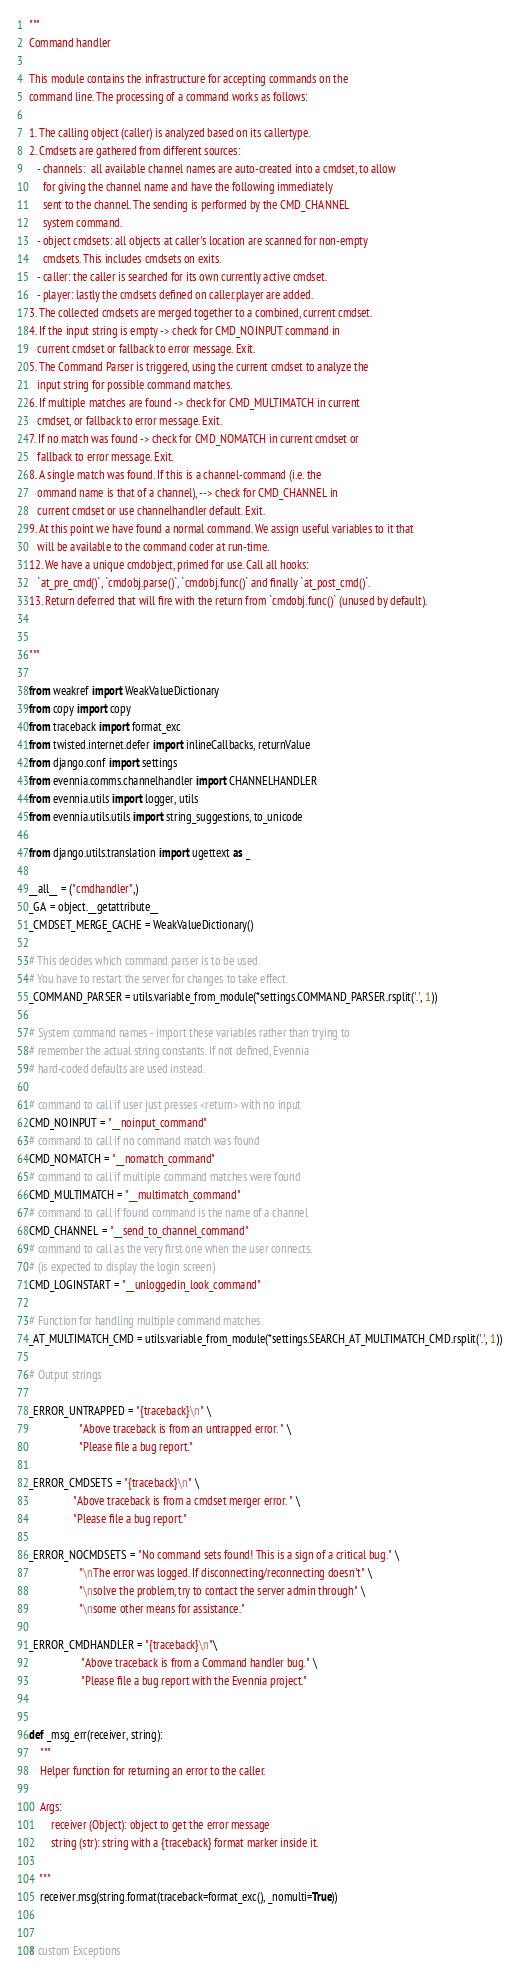<code> <loc_0><loc_0><loc_500><loc_500><_Python_>"""
Command handler

This module contains the infrastructure for accepting commands on the
command line. The processing of a command works as follows:

1. The calling object (caller) is analyzed based on its callertype.
2. Cmdsets are gathered from different sources:
   - channels:  all available channel names are auto-created into a cmdset, to allow
     for giving the channel name and have the following immediately
     sent to the channel. The sending is performed by the CMD_CHANNEL
     system command.
   - object cmdsets: all objects at caller's location are scanned for non-empty
     cmdsets. This includes cmdsets on exits.
   - caller: the caller is searched for its own currently active cmdset.
   - player: lastly the cmdsets defined on caller.player are added.
3. The collected cmdsets are merged together to a combined, current cmdset.
4. If the input string is empty -> check for CMD_NOINPUT command in
   current cmdset or fallback to error message. Exit.
5. The Command Parser is triggered, using the current cmdset to analyze the
   input string for possible command matches.
6. If multiple matches are found -> check for CMD_MULTIMATCH in current
   cmdset, or fallback to error message. Exit.
7. If no match was found -> check for CMD_NOMATCH in current cmdset or
   fallback to error message. Exit.
8. A single match was found. If this is a channel-command (i.e. the
   ommand name is that of a channel), --> check for CMD_CHANNEL in
   current cmdset or use channelhandler default. Exit.
9. At this point we have found a normal command. We assign useful variables to it that
   will be available to the command coder at run-time.
12. We have a unique cmdobject, primed for use. Call all hooks:
   `at_pre_cmd()`, `cmdobj.parse()`, `cmdobj.func()` and finally `at_post_cmd()`.
13. Return deferred that will fire with the return from `cmdobj.func()` (unused by default).


"""

from weakref import WeakValueDictionary
from copy import copy
from traceback import format_exc
from twisted.internet.defer import inlineCallbacks, returnValue
from django.conf import settings
from evennia.comms.channelhandler import CHANNELHANDLER
from evennia.utils import logger, utils
from evennia.utils.utils import string_suggestions, to_unicode

from django.utils.translation import ugettext as _

__all__ = ("cmdhandler",)
_GA = object.__getattribute__
_CMDSET_MERGE_CACHE = WeakValueDictionary()

# This decides which command parser is to be used.
# You have to restart the server for changes to take effect.
_COMMAND_PARSER = utils.variable_from_module(*settings.COMMAND_PARSER.rsplit('.', 1))

# System command names - import these variables rather than trying to
# remember the actual string constants. If not defined, Evennia
# hard-coded defaults are used instead.

# command to call if user just presses <return> with no input
CMD_NOINPUT = "__noinput_command"
# command to call if no command match was found
CMD_NOMATCH = "__nomatch_command"
# command to call if multiple command matches were found
CMD_MULTIMATCH = "__multimatch_command"
# command to call if found command is the name of a channel
CMD_CHANNEL = "__send_to_channel_command"
# command to call as the very first one when the user connects.
# (is expected to display the login screen)
CMD_LOGINSTART = "__unloggedin_look_command"

# Function for handling multiple command matches.
_AT_MULTIMATCH_CMD = utils.variable_from_module(*settings.SEARCH_AT_MULTIMATCH_CMD.rsplit('.', 1))

# Output strings

_ERROR_UNTRAPPED = "{traceback}\n" \
                  "Above traceback is from an untrapped error. " \
                  "Please file a bug report."

_ERROR_CMDSETS = "{traceback}\n" \
                "Above traceback is from a cmdset merger error. " \
                "Please file a bug report."

_ERROR_NOCMDSETS = "No command sets found! This is a sign of a critical bug." \
                  "\nThe error was logged. If disconnecting/reconnecting doesn't" \
                  "\nsolve the problem, try to contact the server admin through" \
                  "\nsome other means for assistance."

_ERROR_CMDHANDLER = "{traceback}\n"\
                   "Above traceback is from a Command handler bug." \
                   "Please file a bug report with the Evennia project."


def _msg_err(receiver, string):
    """
    Helper function for returning an error to the caller.

    Args:
        receiver (Object): object to get the error message
        string (str): string with a {traceback} format marker inside it.

    """
    receiver.msg(string.format(traceback=format_exc(), _nomulti=True))


# custom Exceptions
</code> 